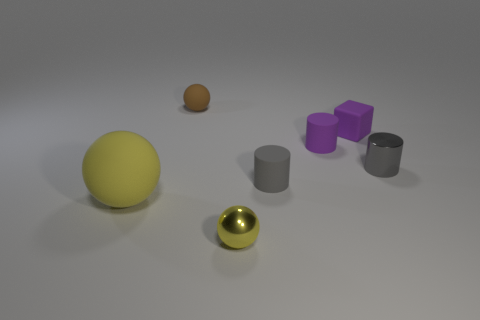Add 1 big yellow rubber balls. How many objects exist? 8 Subtract all cylinders. How many objects are left? 4 Add 1 rubber things. How many rubber things are left? 6 Add 7 red shiny balls. How many red shiny balls exist? 7 Subtract 2 gray cylinders. How many objects are left? 5 Subtract all small purple matte cylinders. Subtract all large yellow rubber balls. How many objects are left? 5 